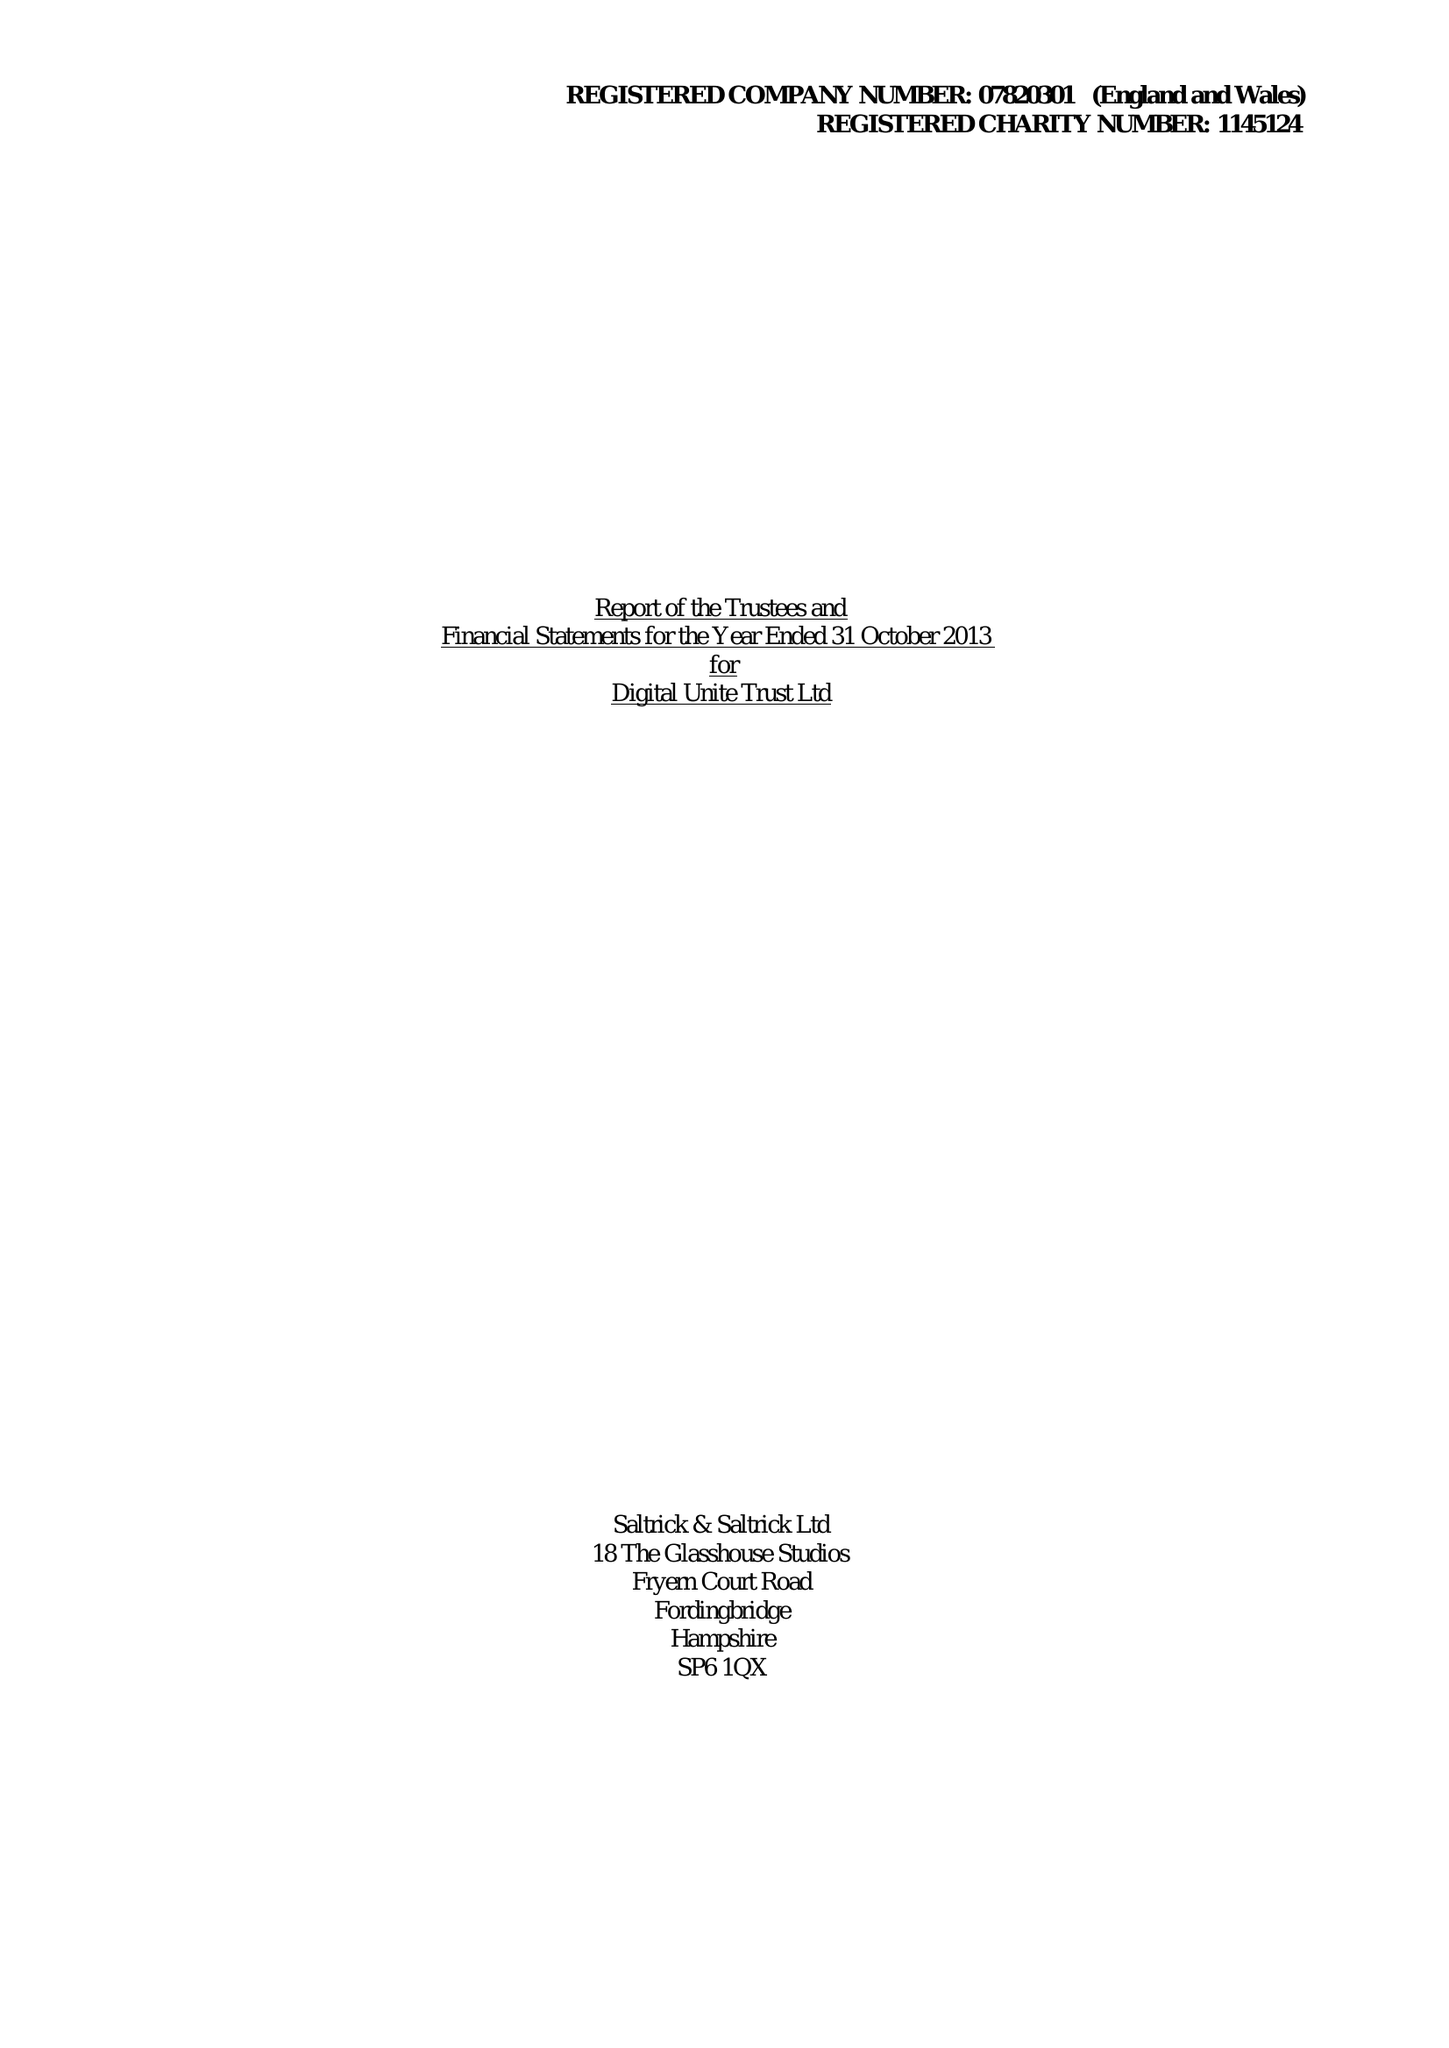What is the value for the address__post_town?
Answer the question using a single word or phrase. FAREHAM 